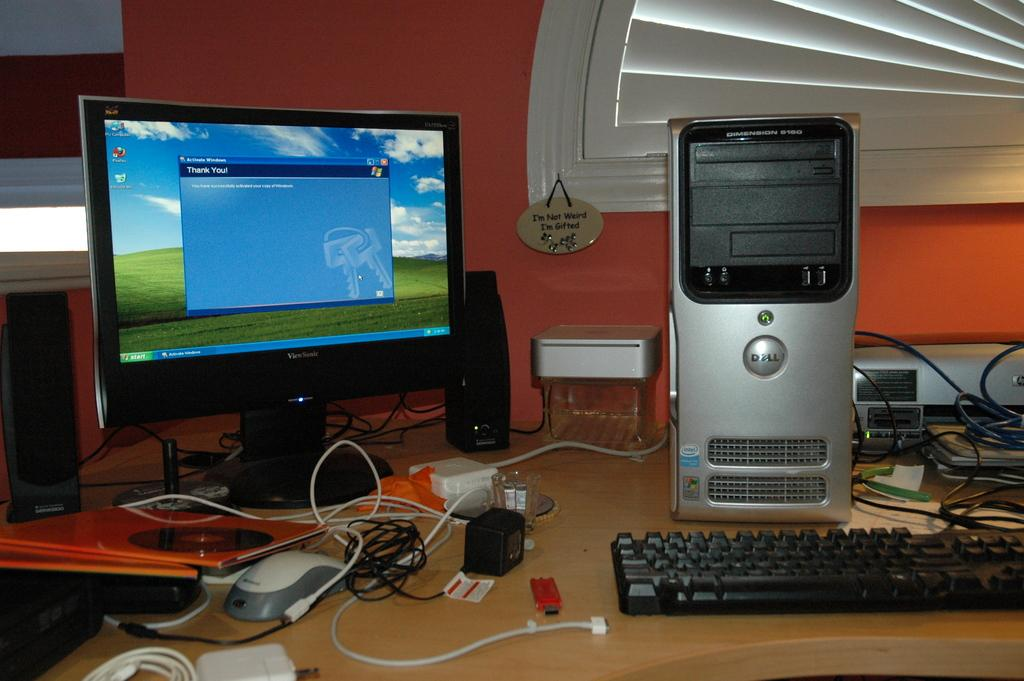Provide a one-sentence caption for the provided image. A computer sits on a desk with a small placard that says "I'm not weird, I'm gifted.". 